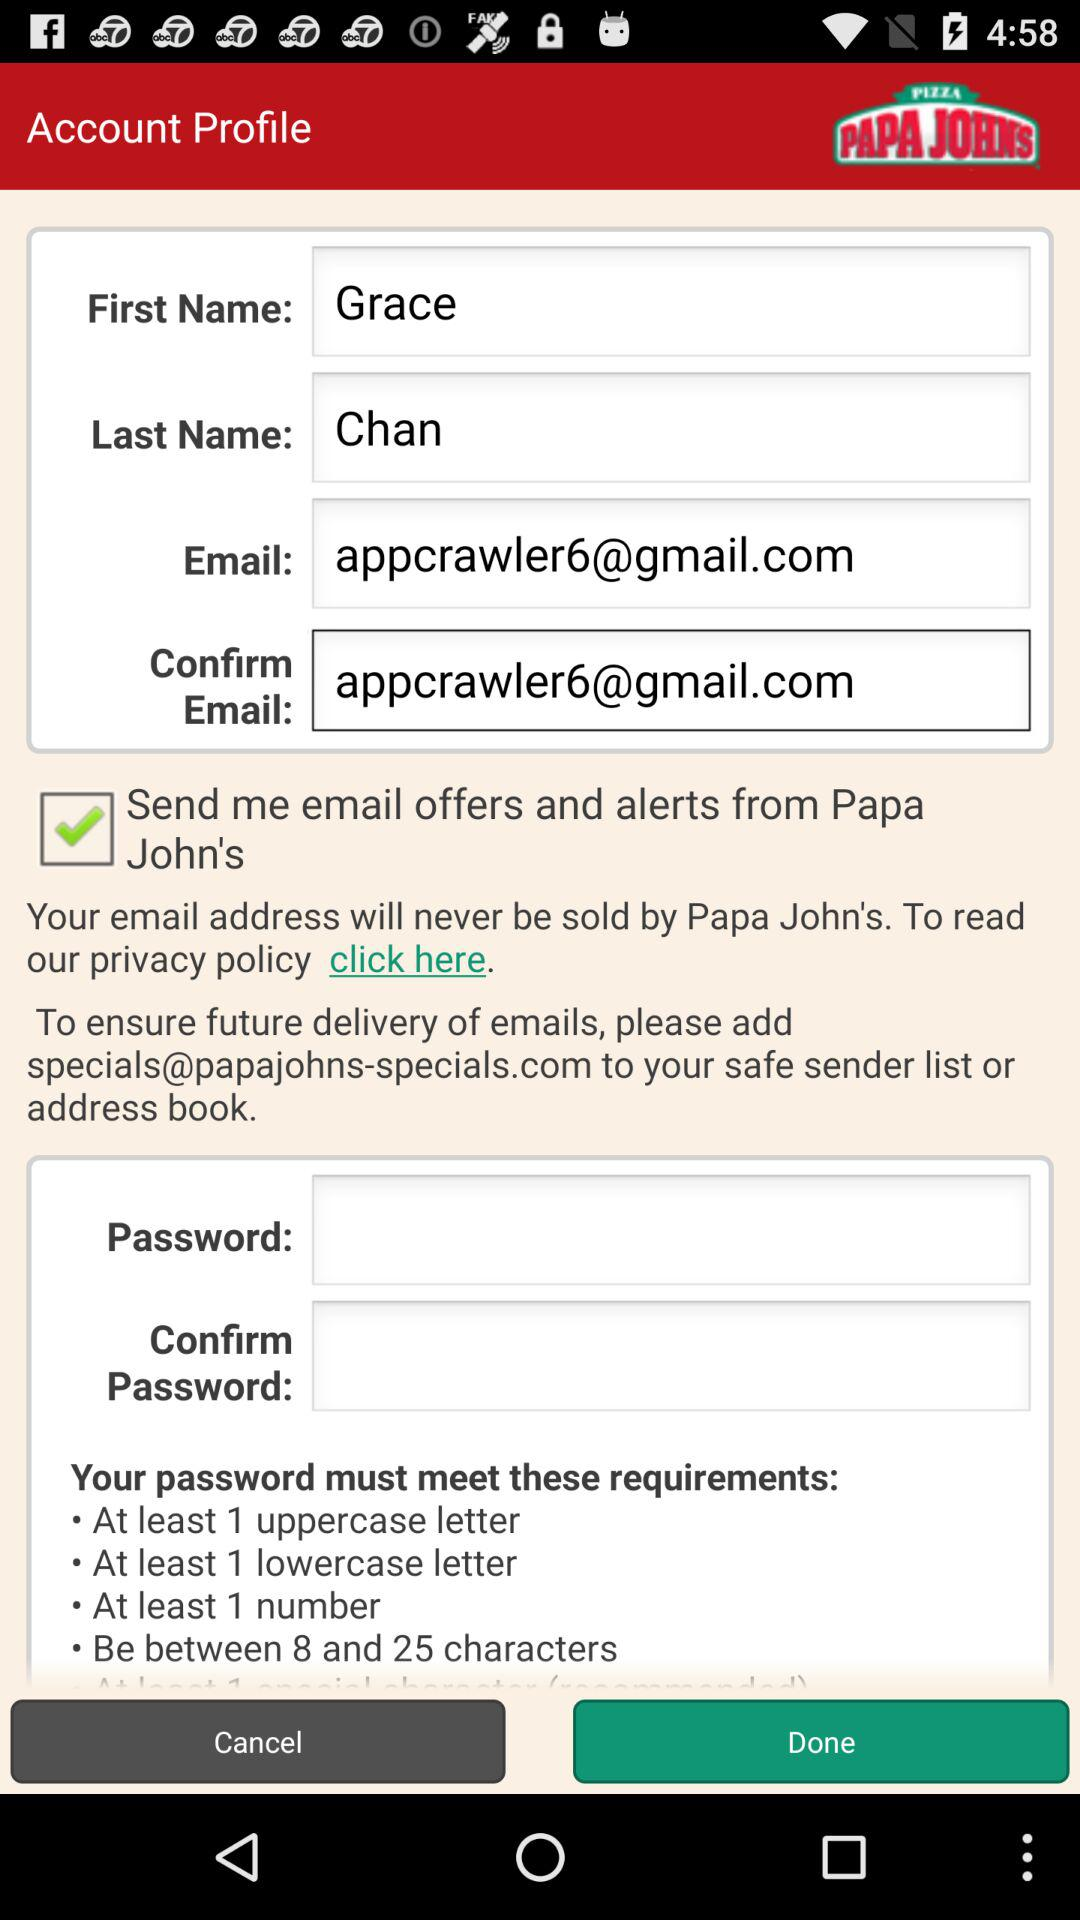How many characters should the password be? The password should be 8 to 25 characters long. 